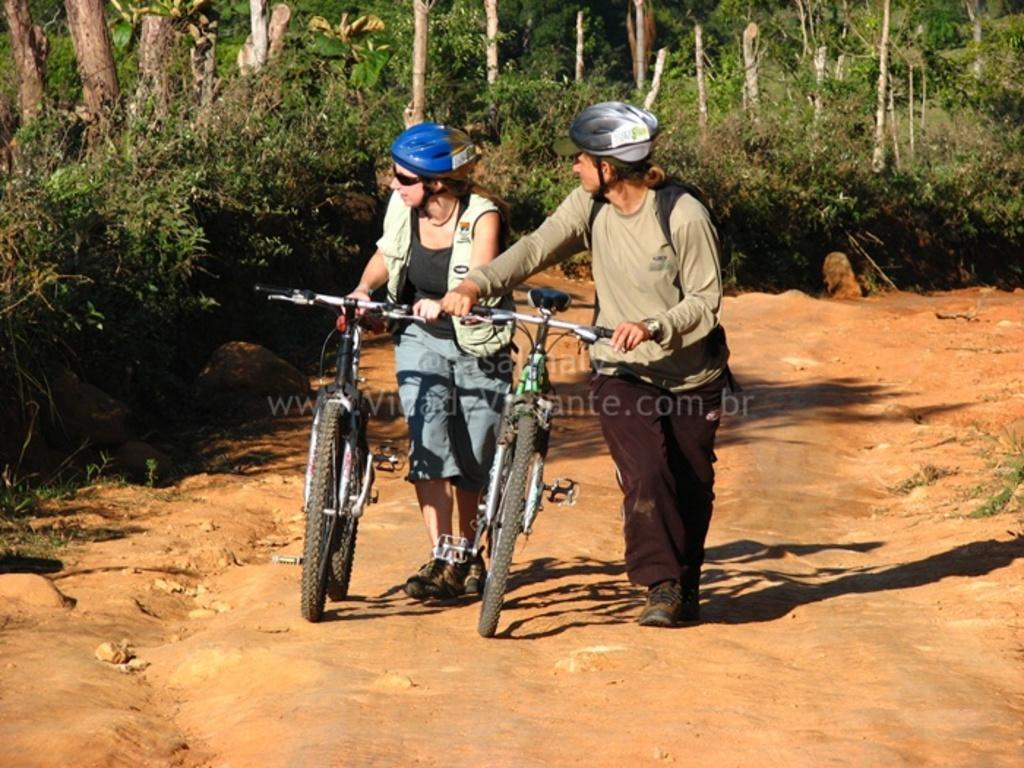How many people are in the image? There are two persons in the image. What are the persons wearing on their heads? The persons are wearing helmets. What are the persons holding in the image? The persons are holding cycles. What type of terrain can be seen in the image? The persons are walking on a mud road. What can be seen in the background of the image? There are trees and plants in the background of the image. What type of drug can be seen in the image? There is no drug present in the image. What is the chin of the person on the left doing in the image? There is no mention of a chin or any specific action related to a chin in the image. 